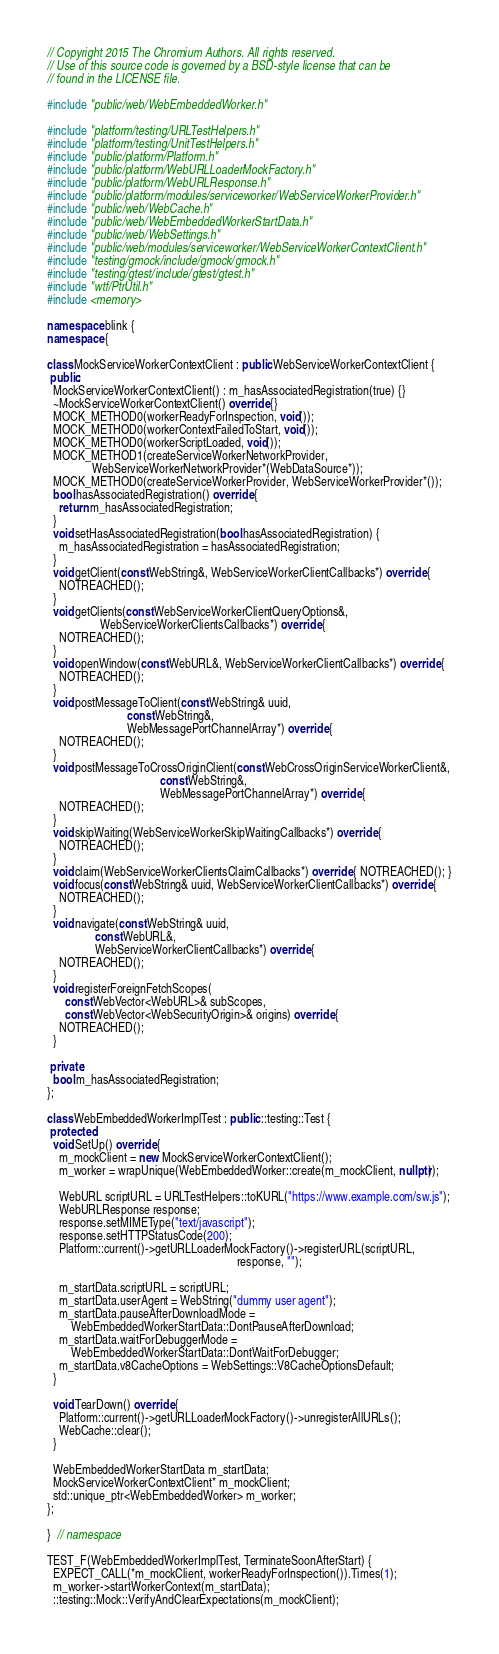<code> <loc_0><loc_0><loc_500><loc_500><_C++_>// Copyright 2015 The Chromium Authors. All rights reserved.
// Use of this source code is governed by a BSD-style license that can be
// found in the LICENSE file.

#include "public/web/WebEmbeddedWorker.h"

#include "platform/testing/URLTestHelpers.h"
#include "platform/testing/UnitTestHelpers.h"
#include "public/platform/Platform.h"
#include "public/platform/WebURLLoaderMockFactory.h"
#include "public/platform/WebURLResponse.h"
#include "public/platform/modules/serviceworker/WebServiceWorkerProvider.h"
#include "public/web/WebCache.h"
#include "public/web/WebEmbeddedWorkerStartData.h"
#include "public/web/WebSettings.h"
#include "public/web/modules/serviceworker/WebServiceWorkerContextClient.h"
#include "testing/gmock/include/gmock/gmock.h"
#include "testing/gtest/include/gtest/gtest.h"
#include "wtf/PtrUtil.h"
#include <memory>

namespace blink {
namespace {

class MockServiceWorkerContextClient : public WebServiceWorkerContextClient {
 public:
  MockServiceWorkerContextClient() : m_hasAssociatedRegistration(true) {}
  ~MockServiceWorkerContextClient() override {}
  MOCK_METHOD0(workerReadyForInspection, void());
  MOCK_METHOD0(workerContextFailedToStart, void());
  MOCK_METHOD0(workerScriptLoaded, void());
  MOCK_METHOD1(createServiceWorkerNetworkProvider,
               WebServiceWorkerNetworkProvider*(WebDataSource*));
  MOCK_METHOD0(createServiceWorkerProvider, WebServiceWorkerProvider*());
  bool hasAssociatedRegistration() override {
    return m_hasAssociatedRegistration;
  }
  void setHasAssociatedRegistration(bool hasAssociatedRegistration) {
    m_hasAssociatedRegistration = hasAssociatedRegistration;
  }
  void getClient(const WebString&, WebServiceWorkerClientCallbacks*) override {
    NOTREACHED();
  }
  void getClients(const WebServiceWorkerClientQueryOptions&,
                  WebServiceWorkerClientsCallbacks*) override {
    NOTREACHED();
  }
  void openWindow(const WebURL&, WebServiceWorkerClientCallbacks*) override {
    NOTREACHED();
  }
  void postMessageToClient(const WebString& uuid,
                           const WebString&,
                           WebMessagePortChannelArray*) override {
    NOTREACHED();
  }
  void postMessageToCrossOriginClient(const WebCrossOriginServiceWorkerClient&,
                                      const WebString&,
                                      WebMessagePortChannelArray*) override {
    NOTREACHED();
  }
  void skipWaiting(WebServiceWorkerSkipWaitingCallbacks*) override {
    NOTREACHED();
  }
  void claim(WebServiceWorkerClientsClaimCallbacks*) override { NOTREACHED(); }
  void focus(const WebString& uuid, WebServiceWorkerClientCallbacks*) override {
    NOTREACHED();
  }
  void navigate(const WebString& uuid,
                const WebURL&,
                WebServiceWorkerClientCallbacks*) override {
    NOTREACHED();
  }
  void registerForeignFetchScopes(
      const WebVector<WebURL>& subScopes,
      const WebVector<WebSecurityOrigin>& origins) override {
    NOTREACHED();
  }

 private:
  bool m_hasAssociatedRegistration;
};

class WebEmbeddedWorkerImplTest : public ::testing::Test {
 protected:
  void SetUp() override {
    m_mockClient = new MockServiceWorkerContextClient();
    m_worker = wrapUnique(WebEmbeddedWorker::create(m_mockClient, nullptr));

    WebURL scriptURL = URLTestHelpers::toKURL("https://www.example.com/sw.js");
    WebURLResponse response;
    response.setMIMEType("text/javascript");
    response.setHTTPStatusCode(200);
    Platform::current()->getURLLoaderMockFactory()->registerURL(scriptURL,
                                                                response, "");

    m_startData.scriptURL = scriptURL;
    m_startData.userAgent = WebString("dummy user agent");
    m_startData.pauseAfterDownloadMode =
        WebEmbeddedWorkerStartData::DontPauseAfterDownload;
    m_startData.waitForDebuggerMode =
        WebEmbeddedWorkerStartData::DontWaitForDebugger;
    m_startData.v8CacheOptions = WebSettings::V8CacheOptionsDefault;
  }

  void TearDown() override {
    Platform::current()->getURLLoaderMockFactory()->unregisterAllURLs();
    WebCache::clear();
  }

  WebEmbeddedWorkerStartData m_startData;
  MockServiceWorkerContextClient* m_mockClient;
  std::unique_ptr<WebEmbeddedWorker> m_worker;
};

}  // namespace

TEST_F(WebEmbeddedWorkerImplTest, TerminateSoonAfterStart) {
  EXPECT_CALL(*m_mockClient, workerReadyForInspection()).Times(1);
  m_worker->startWorkerContext(m_startData);
  ::testing::Mock::VerifyAndClearExpectations(m_mockClient);
</code> 